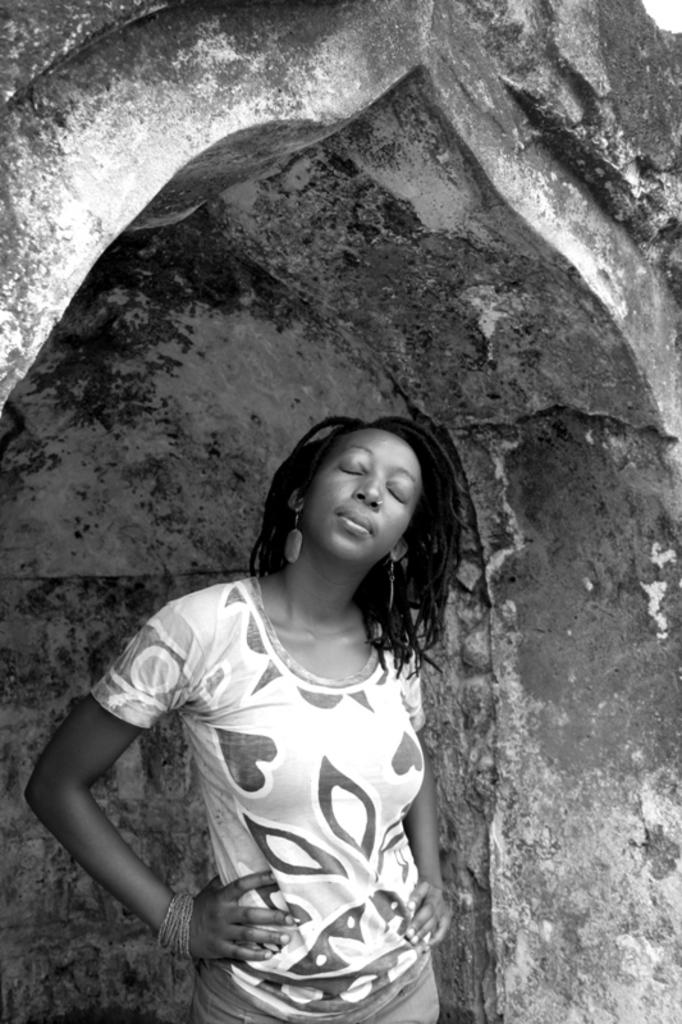What is the color scheme of the image? The image is black and white. What can be seen in the foreground of the image? There is a woman standing in the image. What is visible in the background of the image? There is a wall visible in the background of the image. Can you hear the bells ringing in the image? There are no bells or ringing sounds present in the image, as it is a still, black and white photograph. 